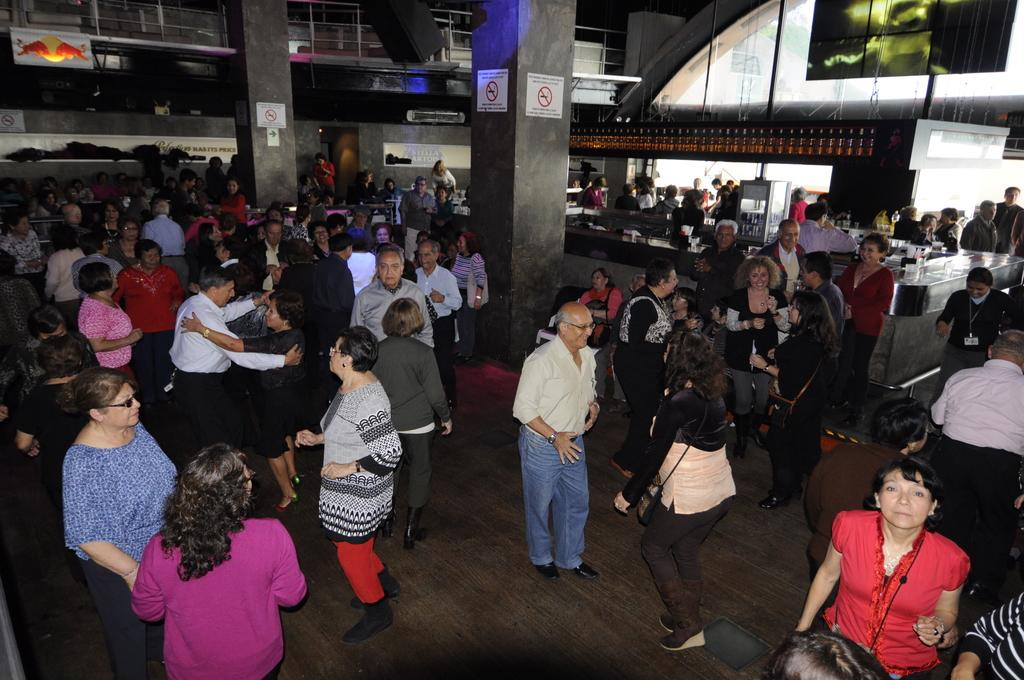What can be seen in the image? There are people in the image, along with posters on pillars, objects on the surface, bottles on a shelf, and other objects present. Can you describe the background of the image? In the background, there are clothes on a surface, a fence, a board, a wall, and a glass object. What might the people in the image be doing? It is not clear from the image what the people are doing, but they are likely interacting with the objects and posters around them. What type of berry is growing on the wall in the background? There are no berries present in the image; the background features a fence, a board, a wall, and a glass object. Can you describe the house in the image? There is no house present in the image; the background features a fence, a board, a wall, and a glass object. Where is the zipper located in the image? There is no zipper present in the image; the objects and subjects in the image include people, posters, bottles, and various surfaces. 